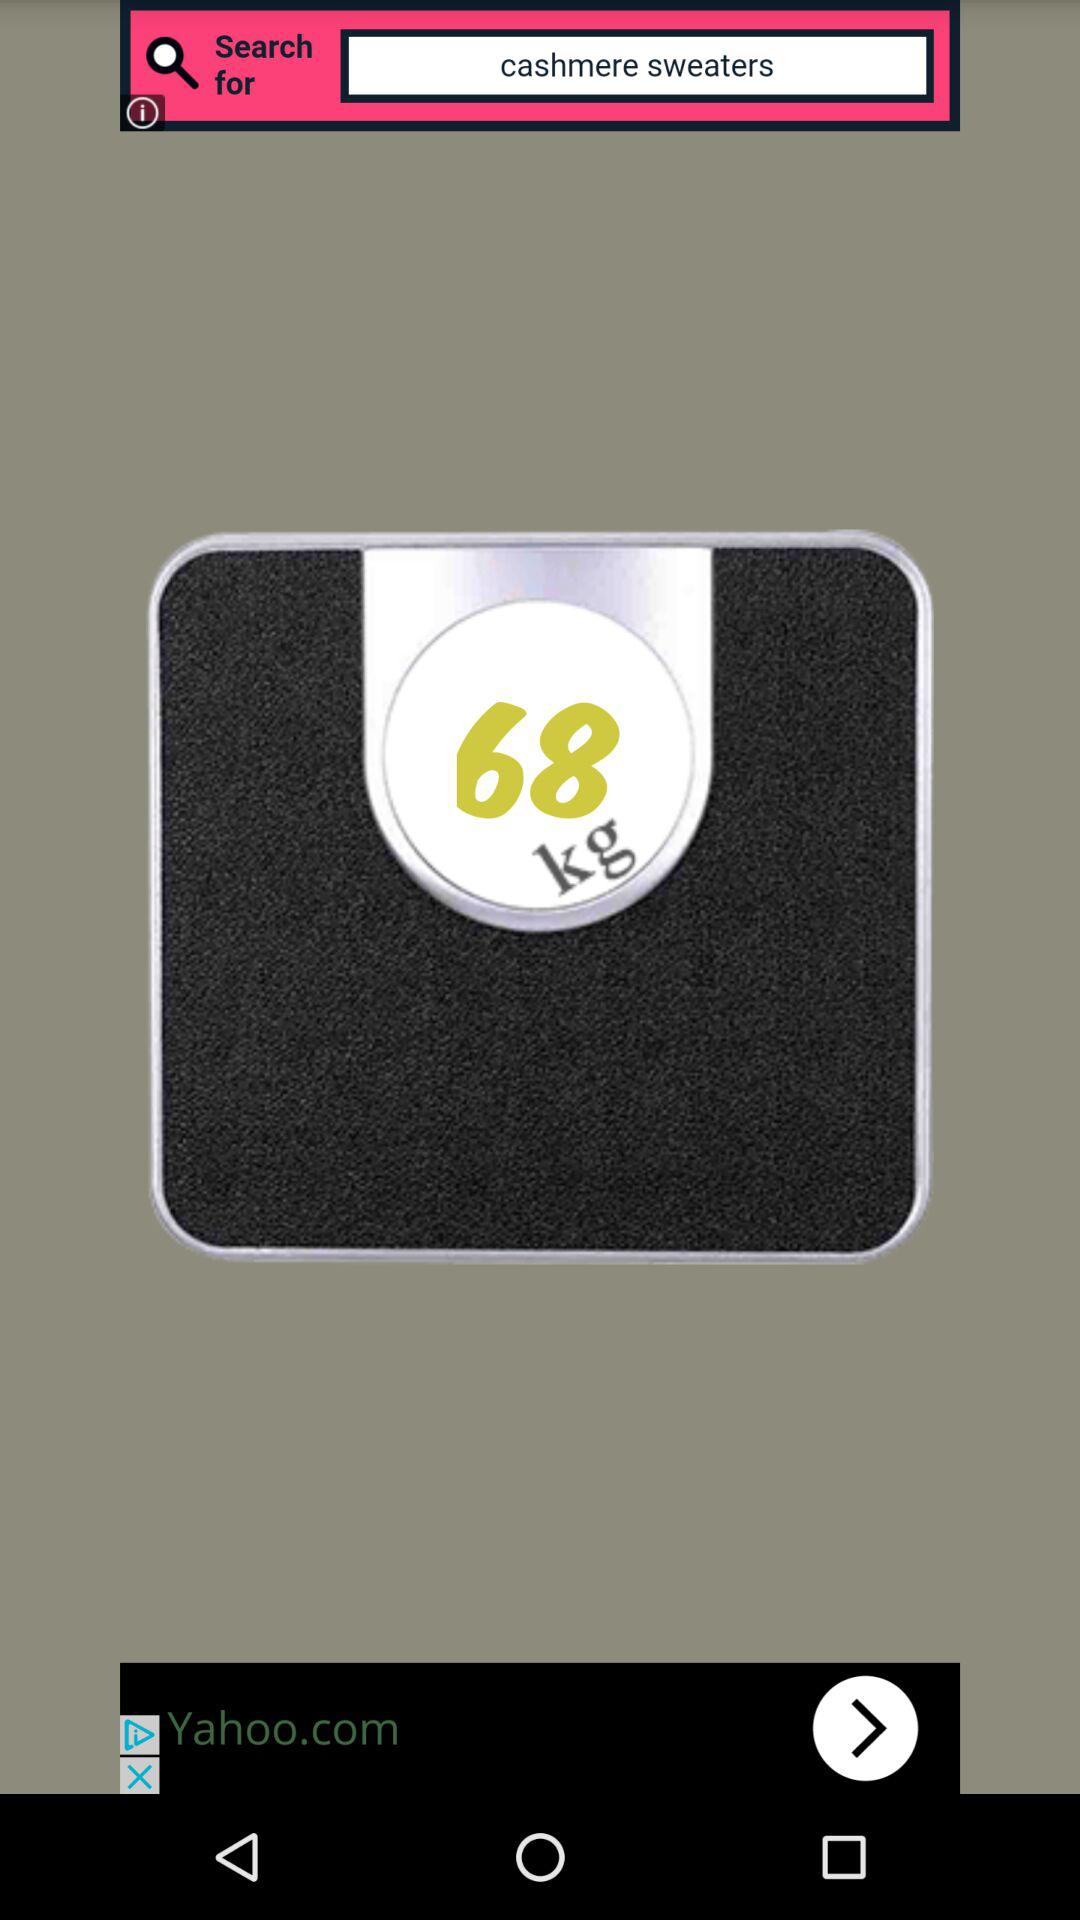How many kilograms is the weight on the scale?
Answer the question using a single word or phrase. 68 